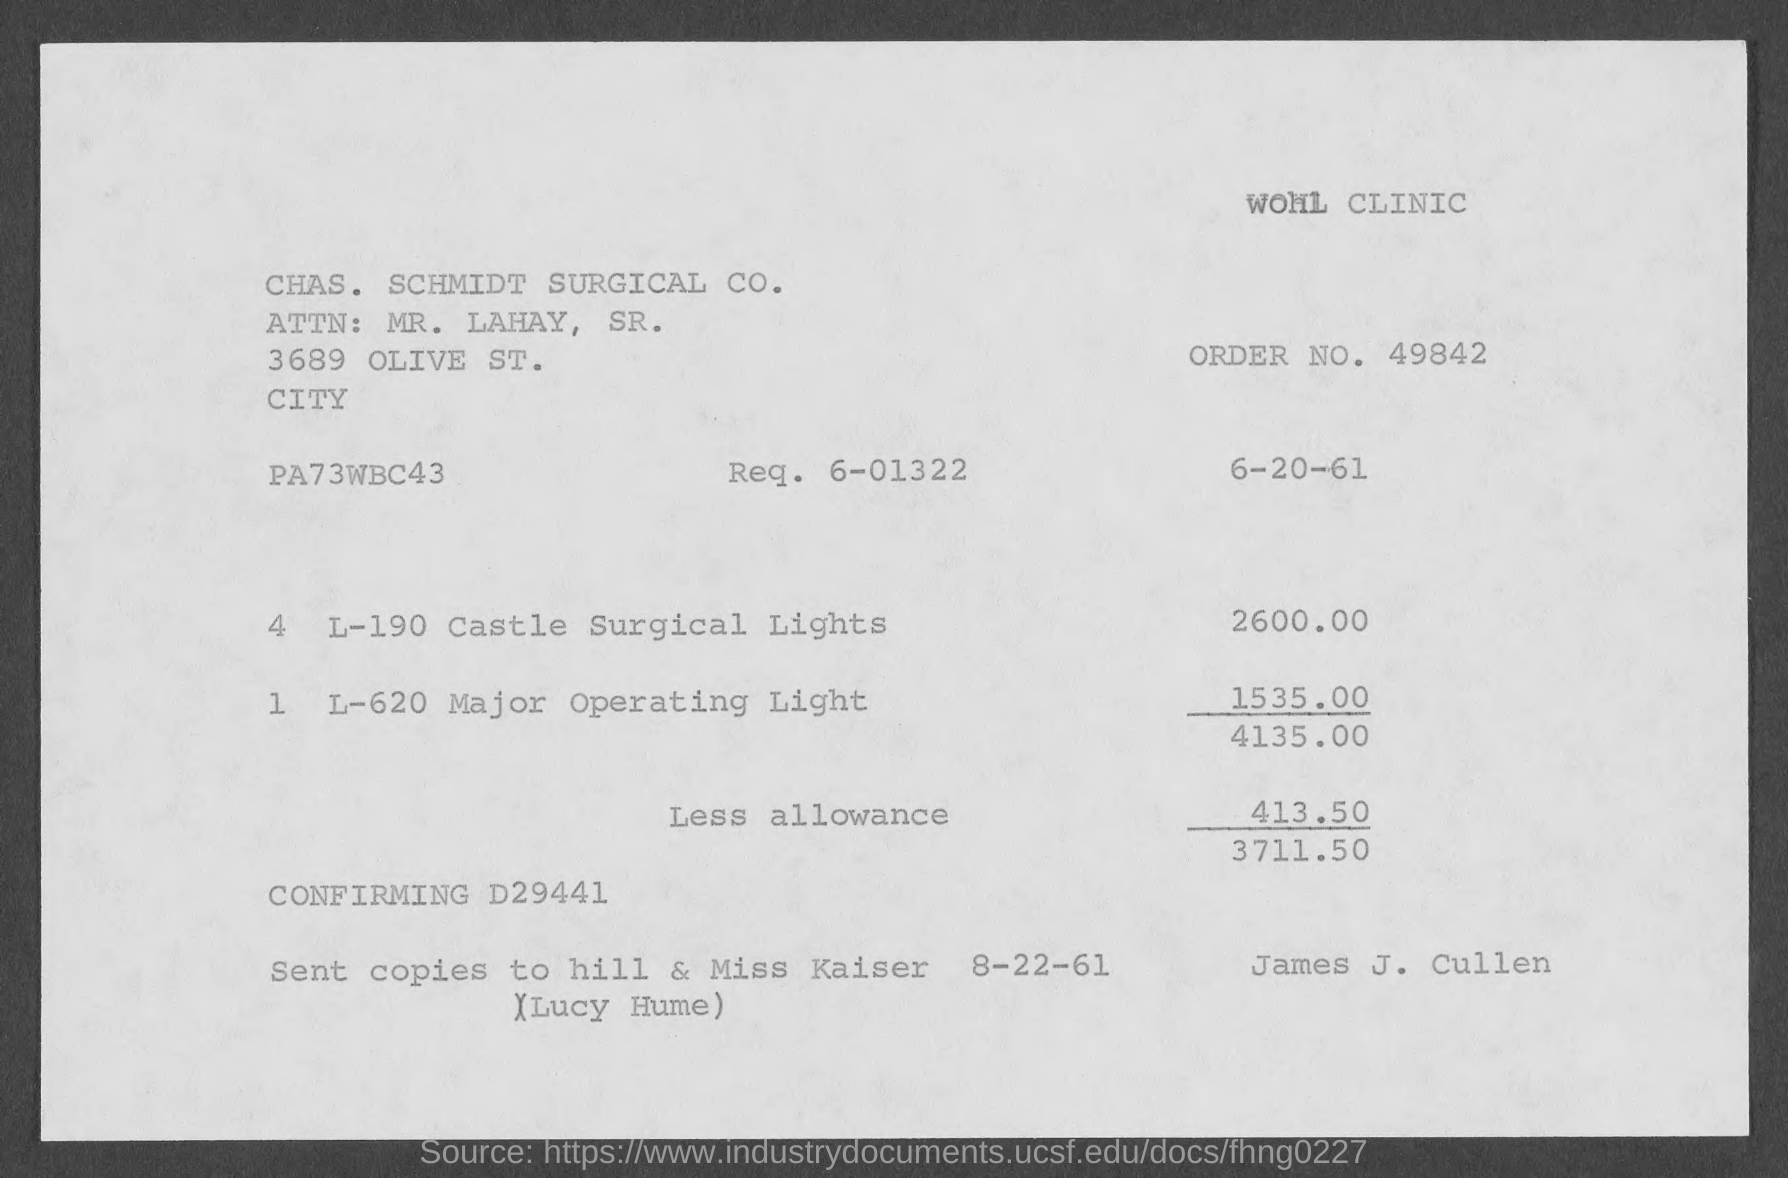Draw attention to some important aspects in this diagram. The cost of Castle surgical lights, as stated on the given page, is $2,600.00. The request number mentioned in the given page is 6-01322. The order number mentioned on the given page is 49842... The amount of less allowance mentioned in the given page is 413.50. The amount for the major operating light mentioned on the given page is 1535.00. 